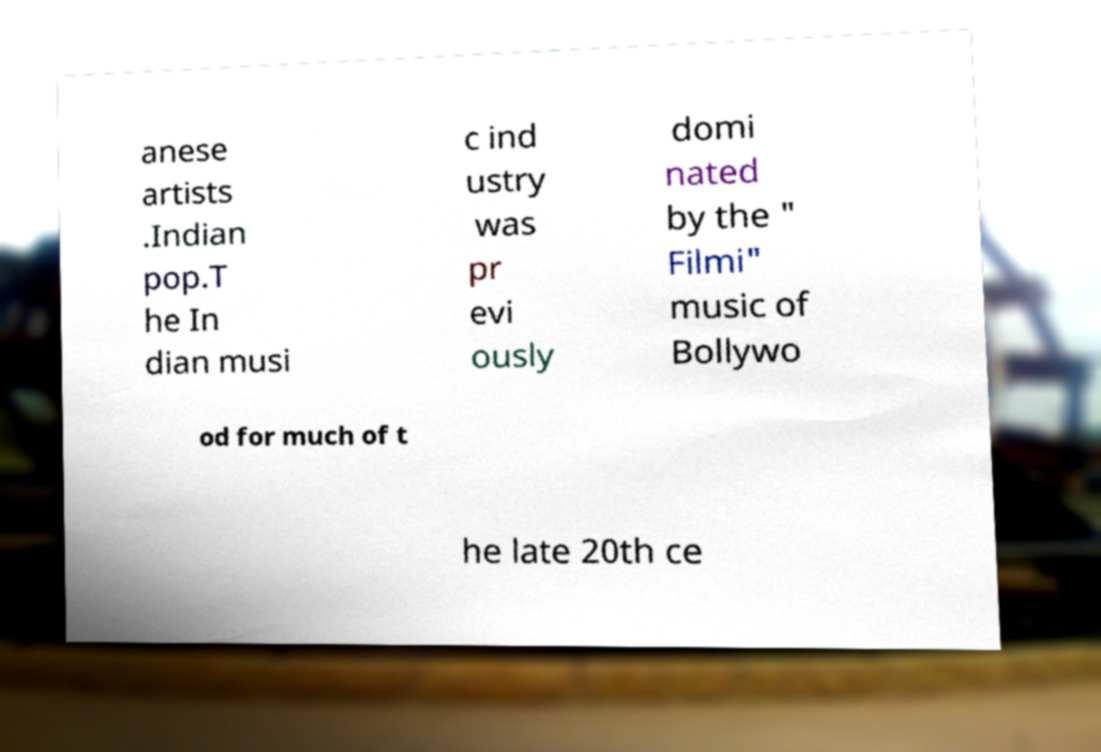Can you read and provide the text displayed in the image?This photo seems to have some interesting text. Can you extract and type it out for me? anese artists .Indian pop.T he In dian musi c ind ustry was pr evi ously domi nated by the " Filmi" music of Bollywo od for much of t he late 20th ce 